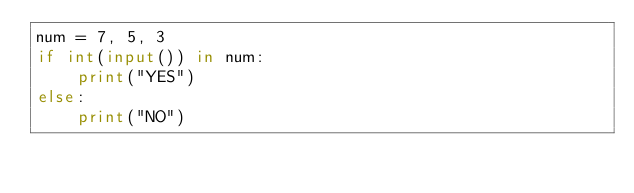<code> <loc_0><loc_0><loc_500><loc_500><_Python_>num = 7, 5, 3
if int(input()) in num:
    print("YES")
else:
    print("NO")</code> 